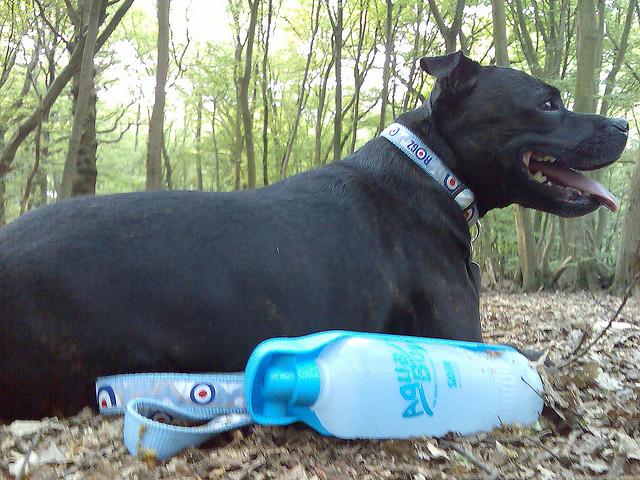What color is the dog?
Keep it brief. Black. What is the plastic bottle on the ground used for?
Short answer required. Water. Is the dog's tongue out?
Concise answer only. Yes. 